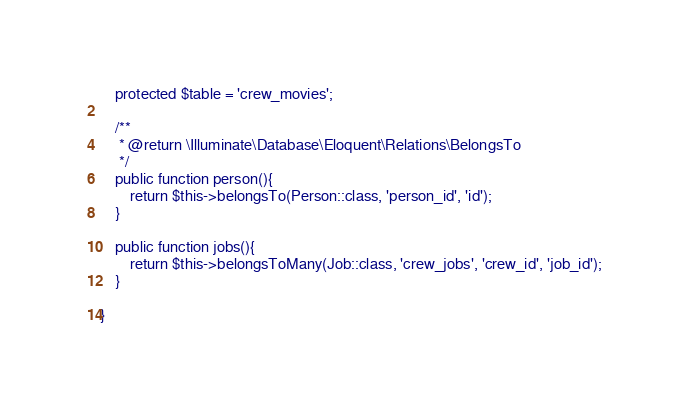<code> <loc_0><loc_0><loc_500><loc_500><_PHP_>    protected $table = 'crew_movies';

    /**
     * @return \Illuminate\Database\Eloquent\Relations\BelongsTo
     */
    public function person(){
        return $this->belongsTo(Person::class, 'person_id', 'id');
    }

    public function jobs(){
        return $this->belongsToMany(Job::class, 'crew_jobs', 'crew_id', 'job_id');
    }

}
</code> 